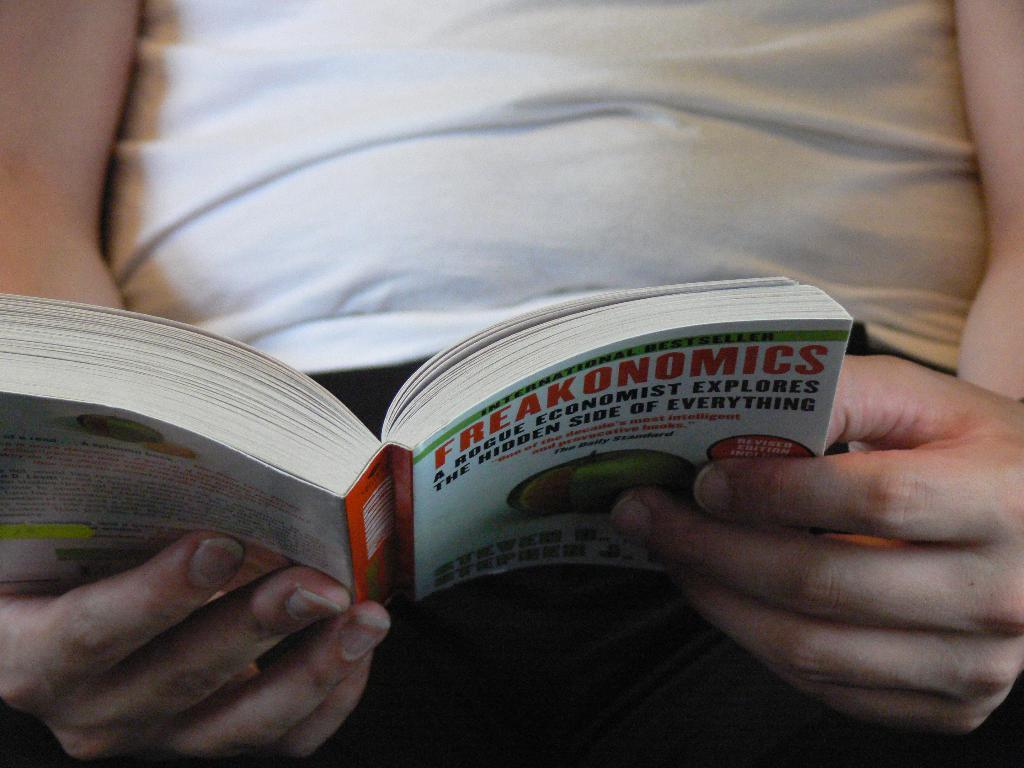<image>
Render a clear and concise summary of the photo. A person is has opened and is reading the book Freakonomics. 